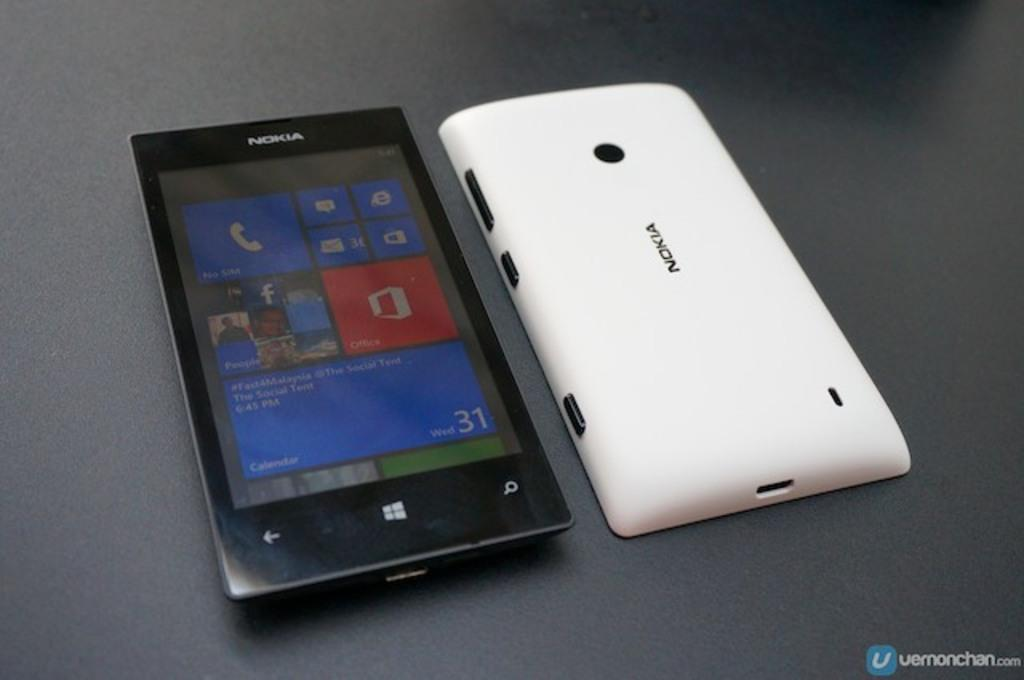<image>
Offer a succinct explanation of the picture presented. a black phone with the screen facing up and a white nokia phone facing down 